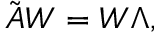<formula> <loc_0><loc_0><loc_500><loc_500>\tilde { A } W = W \Lambda ,</formula> 